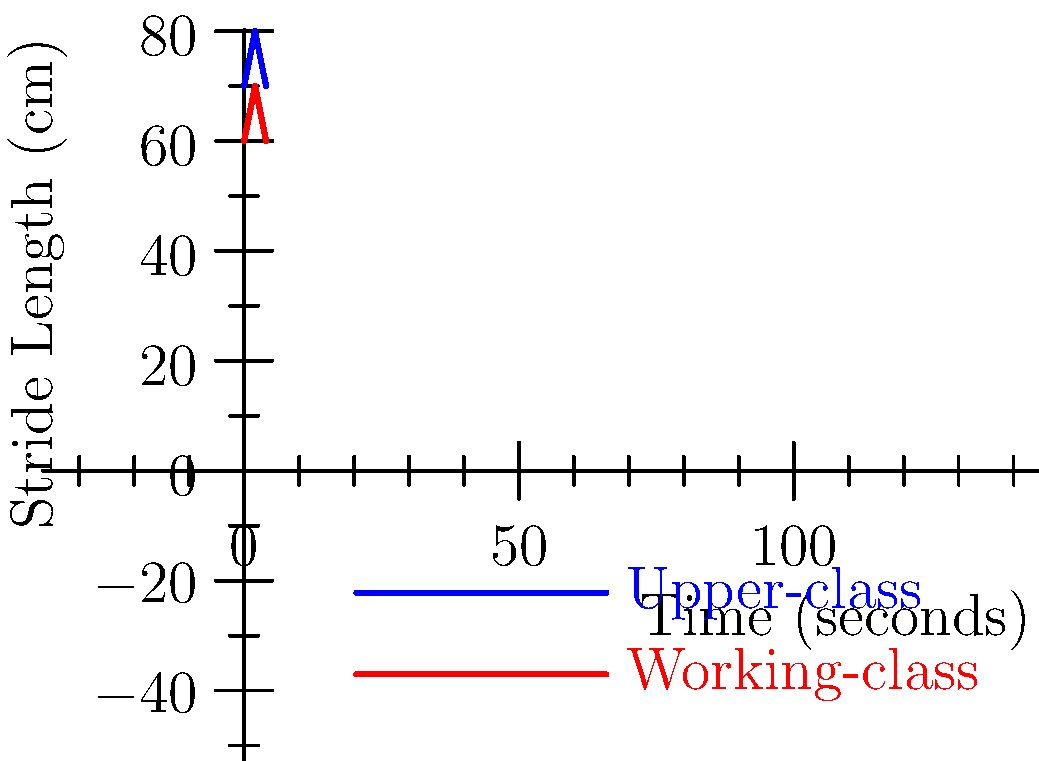Based on the graph comparing gait patterns between upper-class and working-class individuals in 19th-century England, what can be inferred about the difference in average stride length between the two groups? Express your answer as a mathematical expression using LaTeX notation. To answer this question, we need to analyze the graph and follow these steps:

1. Identify the average stride length for each class:
   - Upper-class: The stride length oscillates between 70 cm and 80 cm.
   - Working-class: The stride length oscillates between 60 cm and 70 cm.

2. Calculate the average stride length for each class:
   - Upper-class: $\frac{70 + 80}{2} = 75$ cm
   - Working-class: $\frac{60 + 70}{2} = 65$ cm

3. Calculate the difference in average stride length:
   Upper-class average - Working-class average = $75 - 65 = 10$ cm

4. Express the difference as a mathematical expression:
   Let $U$ represent the average upper-class stride length and $W$ represent the average working-class stride length.

   The difference can be expressed as: $U - W = 10$ cm

This analysis reveals that upper-class individuals generally had a longer stride length compared to working-class individuals, which could be attributed to factors such as differences in footwear, clothing, nutrition, and daily physical activities between the two social classes during the Victorian era.
Answer: $U - W = 10$ cm 